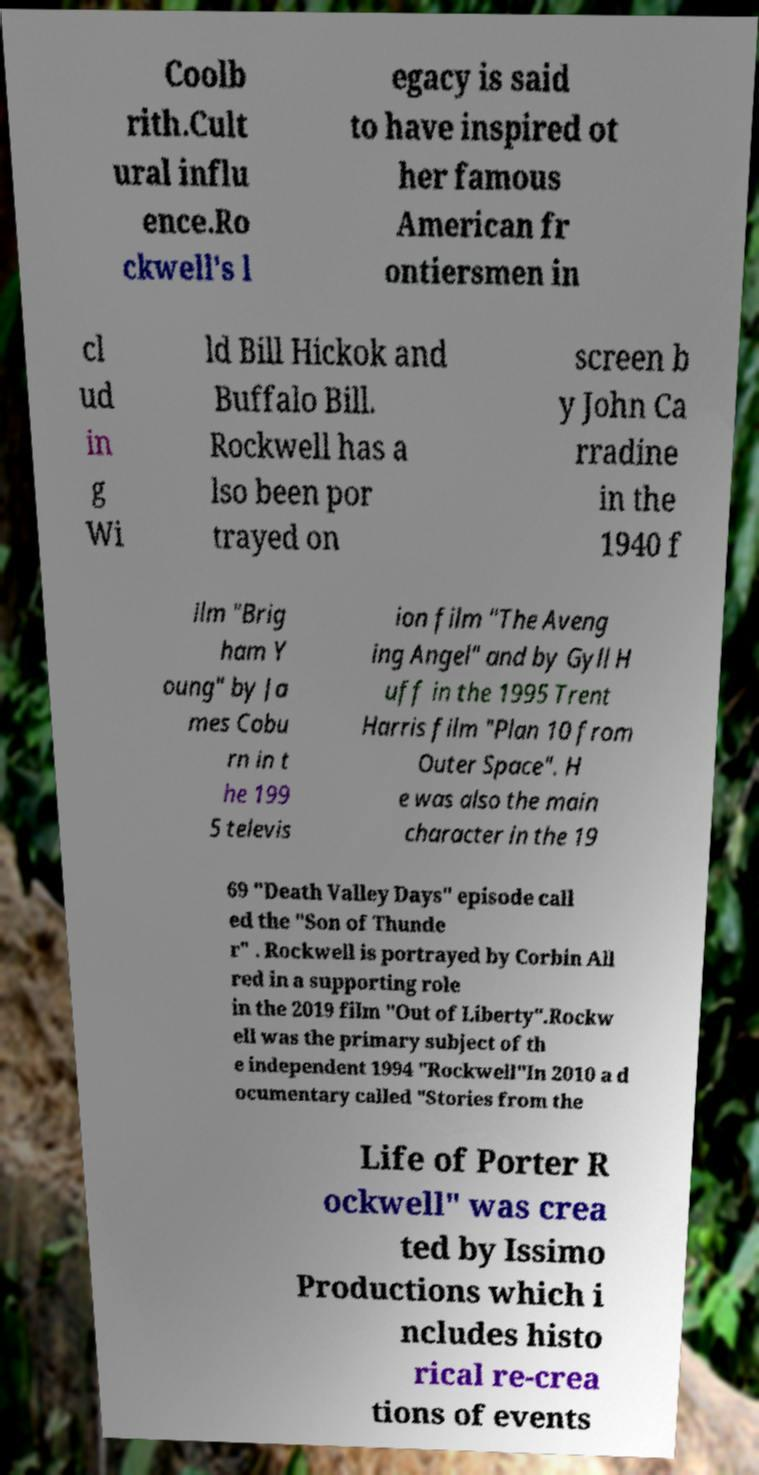Could you extract and type out the text from this image? Coolb rith.Cult ural influ ence.Ro ckwell's l egacy is said to have inspired ot her famous American fr ontiersmen in cl ud in g Wi ld Bill Hickok and Buffalo Bill. Rockwell has a lso been por trayed on screen b y John Ca rradine in the 1940 f ilm "Brig ham Y oung" by Ja mes Cobu rn in t he 199 5 televis ion film "The Aveng ing Angel" and by Gyll H uff in the 1995 Trent Harris film "Plan 10 from Outer Space". H e was also the main character in the 19 69 "Death Valley Days" episode call ed the "Son of Thunde r" . Rockwell is portrayed by Corbin All red in a supporting role in the 2019 film "Out of Liberty".Rockw ell was the primary subject of th e independent 1994 "Rockwell"In 2010 a d ocumentary called "Stories from the Life of Porter R ockwell" was crea ted by Issimo Productions which i ncludes histo rical re-crea tions of events 